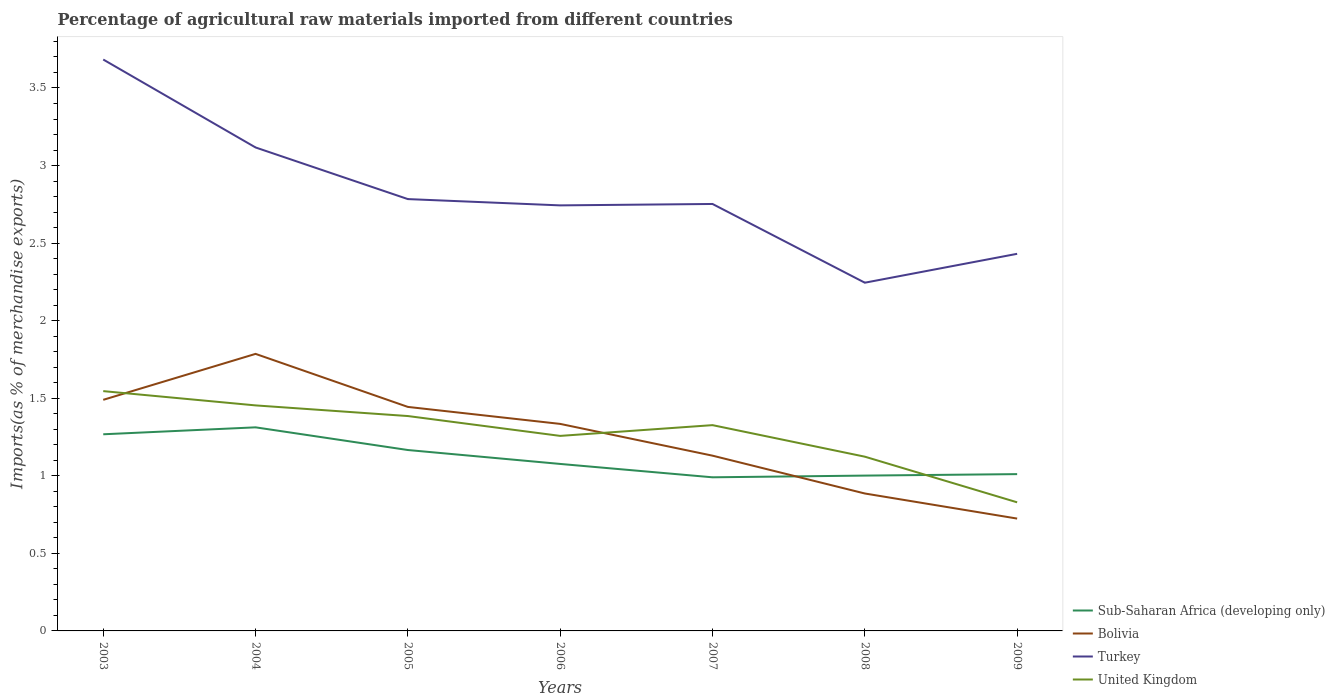Across all years, what is the maximum percentage of imports to different countries in Bolivia?
Provide a succinct answer. 0.72. What is the total percentage of imports to different countries in United Kingdom in the graph?
Keep it short and to the point. 0.43. What is the difference between the highest and the second highest percentage of imports to different countries in Sub-Saharan Africa (developing only)?
Provide a short and direct response. 0.32. Is the percentage of imports to different countries in Sub-Saharan Africa (developing only) strictly greater than the percentage of imports to different countries in Turkey over the years?
Give a very brief answer. Yes. How many lines are there?
Your answer should be compact. 4. How many years are there in the graph?
Offer a very short reply. 7. Are the values on the major ticks of Y-axis written in scientific E-notation?
Ensure brevity in your answer.  No. Does the graph contain grids?
Ensure brevity in your answer.  No. How many legend labels are there?
Offer a terse response. 4. What is the title of the graph?
Offer a very short reply. Percentage of agricultural raw materials imported from different countries. Does "Croatia" appear as one of the legend labels in the graph?
Your answer should be very brief. No. What is the label or title of the X-axis?
Your answer should be very brief. Years. What is the label or title of the Y-axis?
Your response must be concise. Imports(as % of merchandise exports). What is the Imports(as % of merchandise exports) of Sub-Saharan Africa (developing only) in 2003?
Make the answer very short. 1.27. What is the Imports(as % of merchandise exports) in Bolivia in 2003?
Give a very brief answer. 1.49. What is the Imports(as % of merchandise exports) in Turkey in 2003?
Your answer should be very brief. 3.68. What is the Imports(as % of merchandise exports) of United Kingdom in 2003?
Your answer should be compact. 1.55. What is the Imports(as % of merchandise exports) in Sub-Saharan Africa (developing only) in 2004?
Offer a terse response. 1.31. What is the Imports(as % of merchandise exports) in Bolivia in 2004?
Ensure brevity in your answer.  1.79. What is the Imports(as % of merchandise exports) of Turkey in 2004?
Offer a terse response. 3.12. What is the Imports(as % of merchandise exports) of United Kingdom in 2004?
Provide a succinct answer. 1.45. What is the Imports(as % of merchandise exports) in Sub-Saharan Africa (developing only) in 2005?
Provide a succinct answer. 1.17. What is the Imports(as % of merchandise exports) in Bolivia in 2005?
Your answer should be compact. 1.44. What is the Imports(as % of merchandise exports) of Turkey in 2005?
Your answer should be compact. 2.78. What is the Imports(as % of merchandise exports) in United Kingdom in 2005?
Your response must be concise. 1.39. What is the Imports(as % of merchandise exports) of Sub-Saharan Africa (developing only) in 2006?
Your answer should be compact. 1.08. What is the Imports(as % of merchandise exports) of Bolivia in 2006?
Your answer should be compact. 1.33. What is the Imports(as % of merchandise exports) in Turkey in 2006?
Your answer should be very brief. 2.74. What is the Imports(as % of merchandise exports) of United Kingdom in 2006?
Provide a succinct answer. 1.26. What is the Imports(as % of merchandise exports) in Sub-Saharan Africa (developing only) in 2007?
Offer a terse response. 0.99. What is the Imports(as % of merchandise exports) in Bolivia in 2007?
Offer a terse response. 1.13. What is the Imports(as % of merchandise exports) of Turkey in 2007?
Offer a terse response. 2.75. What is the Imports(as % of merchandise exports) in United Kingdom in 2007?
Your response must be concise. 1.33. What is the Imports(as % of merchandise exports) in Sub-Saharan Africa (developing only) in 2008?
Provide a succinct answer. 1. What is the Imports(as % of merchandise exports) of Bolivia in 2008?
Your answer should be compact. 0.89. What is the Imports(as % of merchandise exports) of Turkey in 2008?
Your answer should be compact. 2.24. What is the Imports(as % of merchandise exports) in United Kingdom in 2008?
Provide a succinct answer. 1.12. What is the Imports(as % of merchandise exports) in Sub-Saharan Africa (developing only) in 2009?
Provide a succinct answer. 1.01. What is the Imports(as % of merchandise exports) of Bolivia in 2009?
Ensure brevity in your answer.  0.72. What is the Imports(as % of merchandise exports) of Turkey in 2009?
Keep it short and to the point. 2.43. What is the Imports(as % of merchandise exports) in United Kingdom in 2009?
Offer a terse response. 0.83. Across all years, what is the maximum Imports(as % of merchandise exports) in Sub-Saharan Africa (developing only)?
Provide a succinct answer. 1.31. Across all years, what is the maximum Imports(as % of merchandise exports) of Bolivia?
Your answer should be compact. 1.79. Across all years, what is the maximum Imports(as % of merchandise exports) in Turkey?
Your answer should be very brief. 3.68. Across all years, what is the maximum Imports(as % of merchandise exports) in United Kingdom?
Provide a short and direct response. 1.55. Across all years, what is the minimum Imports(as % of merchandise exports) of Sub-Saharan Africa (developing only)?
Make the answer very short. 0.99. Across all years, what is the minimum Imports(as % of merchandise exports) in Bolivia?
Provide a succinct answer. 0.72. Across all years, what is the minimum Imports(as % of merchandise exports) of Turkey?
Provide a succinct answer. 2.24. Across all years, what is the minimum Imports(as % of merchandise exports) in United Kingdom?
Give a very brief answer. 0.83. What is the total Imports(as % of merchandise exports) of Sub-Saharan Africa (developing only) in the graph?
Ensure brevity in your answer.  7.83. What is the total Imports(as % of merchandise exports) in Bolivia in the graph?
Keep it short and to the point. 8.79. What is the total Imports(as % of merchandise exports) of Turkey in the graph?
Your answer should be compact. 19.76. What is the total Imports(as % of merchandise exports) of United Kingdom in the graph?
Your answer should be compact. 8.92. What is the difference between the Imports(as % of merchandise exports) of Sub-Saharan Africa (developing only) in 2003 and that in 2004?
Offer a terse response. -0.04. What is the difference between the Imports(as % of merchandise exports) in Bolivia in 2003 and that in 2004?
Keep it short and to the point. -0.3. What is the difference between the Imports(as % of merchandise exports) in Turkey in 2003 and that in 2004?
Offer a terse response. 0.57. What is the difference between the Imports(as % of merchandise exports) of United Kingdom in 2003 and that in 2004?
Keep it short and to the point. 0.09. What is the difference between the Imports(as % of merchandise exports) in Sub-Saharan Africa (developing only) in 2003 and that in 2005?
Provide a succinct answer. 0.1. What is the difference between the Imports(as % of merchandise exports) of Bolivia in 2003 and that in 2005?
Keep it short and to the point. 0.05. What is the difference between the Imports(as % of merchandise exports) of Turkey in 2003 and that in 2005?
Keep it short and to the point. 0.9. What is the difference between the Imports(as % of merchandise exports) in United Kingdom in 2003 and that in 2005?
Keep it short and to the point. 0.16. What is the difference between the Imports(as % of merchandise exports) in Sub-Saharan Africa (developing only) in 2003 and that in 2006?
Keep it short and to the point. 0.19. What is the difference between the Imports(as % of merchandise exports) of Bolivia in 2003 and that in 2006?
Provide a short and direct response. 0.16. What is the difference between the Imports(as % of merchandise exports) of Turkey in 2003 and that in 2006?
Make the answer very short. 0.94. What is the difference between the Imports(as % of merchandise exports) in United Kingdom in 2003 and that in 2006?
Make the answer very short. 0.29. What is the difference between the Imports(as % of merchandise exports) of Sub-Saharan Africa (developing only) in 2003 and that in 2007?
Give a very brief answer. 0.28. What is the difference between the Imports(as % of merchandise exports) of Bolivia in 2003 and that in 2007?
Provide a short and direct response. 0.36. What is the difference between the Imports(as % of merchandise exports) of Turkey in 2003 and that in 2007?
Provide a succinct answer. 0.93. What is the difference between the Imports(as % of merchandise exports) of United Kingdom in 2003 and that in 2007?
Offer a terse response. 0.22. What is the difference between the Imports(as % of merchandise exports) in Sub-Saharan Africa (developing only) in 2003 and that in 2008?
Offer a very short reply. 0.27. What is the difference between the Imports(as % of merchandise exports) of Bolivia in 2003 and that in 2008?
Provide a succinct answer. 0.6. What is the difference between the Imports(as % of merchandise exports) in Turkey in 2003 and that in 2008?
Keep it short and to the point. 1.44. What is the difference between the Imports(as % of merchandise exports) of United Kingdom in 2003 and that in 2008?
Your answer should be very brief. 0.42. What is the difference between the Imports(as % of merchandise exports) of Sub-Saharan Africa (developing only) in 2003 and that in 2009?
Your answer should be very brief. 0.26. What is the difference between the Imports(as % of merchandise exports) of Bolivia in 2003 and that in 2009?
Provide a short and direct response. 0.77. What is the difference between the Imports(as % of merchandise exports) in Turkey in 2003 and that in 2009?
Your answer should be compact. 1.25. What is the difference between the Imports(as % of merchandise exports) in United Kingdom in 2003 and that in 2009?
Offer a very short reply. 0.72. What is the difference between the Imports(as % of merchandise exports) of Sub-Saharan Africa (developing only) in 2004 and that in 2005?
Offer a terse response. 0.15. What is the difference between the Imports(as % of merchandise exports) in Bolivia in 2004 and that in 2005?
Keep it short and to the point. 0.34. What is the difference between the Imports(as % of merchandise exports) in Turkey in 2004 and that in 2005?
Give a very brief answer. 0.33. What is the difference between the Imports(as % of merchandise exports) of United Kingdom in 2004 and that in 2005?
Offer a very short reply. 0.07. What is the difference between the Imports(as % of merchandise exports) of Sub-Saharan Africa (developing only) in 2004 and that in 2006?
Provide a short and direct response. 0.24. What is the difference between the Imports(as % of merchandise exports) in Bolivia in 2004 and that in 2006?
Keep it short and to the point. 0.45. What is the difference between the Imports(as % of merchandise exports) in Turkey in 2004 and that in 2006?
Provide a short and direct response. 0.37. What is the difference between the Imports(as % of merchandise exports) in United Kingdom in 2004 and that in 2006?
Make the answer very short. 0.2. What is the difference between the Imports(as % of merchandise exports) of Sub-Saharan Africa (developing only) in 2004 and that in 2007?
Ensure brevity in your answer.  0.32. What is the difference between the Imports(as % of merchandise exports) of Bolivia in 2004 and that in 2007?
Provide a succinct answer. 0.66. What is the difference between the Imports(as % of merchandise exports) in Turkey in 2004 and that in 2007?
Your answer should be compact. 0.36. What is the difference between the Imports(as % of merchandise exports) of United Kingdom in 2004 and that in 2007?
Offer a terse response. 0.13. What is the difference between the Imports(as % of merchandise exports) in Sub-Saharan Africa (developing only) in 2004 and that in 2008?
Offer a very short reply. 0.31. What is the difference between the Imports(as % of merchandise exports) in Bolivia in 2004 and that in 2008?
Offer a very short reply. 0.9. What is the difference between the Imports(as % of merchandise exports) in Turkey in 2004 and that in 2008?
Provide a short and direct response. 0.87. What is the difference between the Imports(as % of merchandise exports) in United Kingdom in 2004 and that in 2008?
Make the answer very short. 0.33. What is the difference between the Imports(as % of merchandise exports) of Sub-Saharan Africa (developing only) in 2004 and that in 2009?
Keep it short and to the point. 0.3. What is the difference between the Imports(as % of merchandise exports) of Bolivia in 2004 and that in 2009?
Your answer should be very brief. 1.06. What is the difference between the Imports(as % of merchandise exports) of Turkey in 2004 and that in 2009?
Your answer should be very brief. 0.69. What is the difference between the Imports(as % of merchandise exports) in United Kingdom in 2004 and that in 2009?
Your response must be concise. 0.62. What is the difference between the Imports(as % of merchandise exports) of Sub-Saharan Africa (developing only) in 2005 and that in 2006?
Keep it short and to the point. 0.09. What is the difference between the Imports(as % of merchandise exports) in Bolivia in 2005 and that in 2006?
Your answer should be very brief. 0.11. What is the difference between the Imports(as % of merchandise exports) in Turkey in 2005 and that in 2006?
Provide a short and direct response. 0.04. What is the difference between the Imports(as % of merchandise exports) in United Kingdom in 2005 and that in 2006?
Keep it short and to the point. 0.13. What is the difference between the Imports(as % of merchandise exports) of Sub-Saharan Africa (developing only) in 2005 and that in 2007?
Ensure brevity in your answer.  0.18. What is the difference between the Imports(as % of merchandise exports) in Bolivia in 2005 and that in 2007?
Your answer should be compact. 0.31. What is the difference between the Imports(as % of merchandise exports) of Turkey in 2005 and that in 2007?
Offer a very short reply. 0.03. What is the difference between the Imports(as % of merchandise exports) in United Kingdom in 2005 and that in 2007?
Offer a terse response. 0.06. What is the difference between the Imports(as % of merchandise exports) of Sub-Saharan Africa (developing only) in 2005 and that in 2008?
Provide a succinct answer. 0.16. What is the difference between the Imports(as % of merchandise exports) of Bolivia in 2005 and that in 2008?
Your response must be concise. 0.56. What is the difference between the Imports(as % of merchandise exports) of Turkey in 2005 and that in 2008?
Keep it short and to the point. 0.54. What is the difference between the Imports(as % of merchandise exports) in United Kingdom in 2005 and that in 2008?
Offer a terse response. 0.26. What is the difference between the Imports(as % of merchandise exports) in Sub-Saharan Africa (developing only) in 2005 and that in 2009?
Offer a terse response. 0.16. What is the difference between the Imports(as % of merchandise exports) in Bolivia in 2005 and that in 2009?
Give a very brief answer. 0.72. What is the difference between the Imports(as % of merchandise exports) of Turkey in 2005 and that in 2009?
Give a very brief answer. 0.35. What is the difference between the Imports(as % of merchandise exports) of United Kingdom in 2005 and that in 2009?
Offer a very short reply. 0.56. What is the difference between the Imports(as % of merchandise exports) of Sub-Saharan Africa (developing only) in 2006 and that in 2007?
Give a very brief answer. 0.09. What is the difference between the Imports(as % of merchandise exports) in Bolivia in 2006 and that in 2007?
Ensure brevity in your answer.  0.2. What is the difference between the Imports(as % of merchandise exports) in Turkey in 2006 and that in 2007?
Offer a very short reply. -0.01. What is the difference between the Imports(as % of merchandise exports) of United Kingdom in 2006 and that in 2007?
Keep it short and to the point. -0.07. What is the difference between the Imports(as % of merchandise exports) in Sub-Saharan Africa (developing only) in 2006 and that in 2008?
Your response must be concise. 0.08. What is the difference between the Imports(as % of merchandise exports) in Bolivia in 2006 and that in 2008?
Keep it short and to the point. 0.45. What is the difference between the Imports(as % of merchandise exports) in Turkey in 2006 and that in 2008?
Ensure brevity in your answer.  0.5. What is the difference between the Imports(as % of merchandise exports) in United Kingdom in 2006 and that in 2008?
Provide a succinct answer. 0.13. What is the difference between the Imports(as % of merchandise exports) of Sub-Saharan Africa (developing only) in 2006 and that in 2009?
Provide a short and direct response. 0.07. What is the difference between the Imports(as % of merchandise exports) in Bolivia in 2006 and that in 2009?
Keep it short and to the point. 0.61. What is the difference between the Imports(as % of merchandise exports) of Turkey in 2006 and that in 2009?
Offer a very short reply. 0.31. What is the difference between the Imports(as % of merchandise exports) of United Kingdom in 2006 and that in 2009?
Offer a very short reply. 0.43. What is the difference between the Imports(as % of merchandise exports) in Sub-Saharan Africa (developing only) in 2007 and that in 2008?
Ensure brevity in your answer.  -0.01. What is the difference between the Imports(as % of merchandise exports) of Bolivia in 2007 and that in 2008?
Provide a succinct answer. 0.24. What is the difference between the Imports(as % of merchandise exports) of Turkey in 2007 and that in 2008?
Ensure brevity in your answer.  0.51. What is the difference between the Imports(as % of merchandise exports) in United Kingdom in 2007 and that in 2008?
Offer a very short reply. 0.2. What is the difference between the Imports(as % of merchandise exports) in Sub-Saharan Africa (developing only) in 2007 and that in 2009?
Make the answer very short. -0.02. What is the difference between the Imports(as % of merchandise exports) of Bolivia in 2007 and that in 2009?
Ensure brevity in your answer.  0.41. What is the difference between the Imports(as % of merchandise exports) in Turkey in 2007 and that in 2009?
Ensure brevity in your answer.  0.32. What is the difference between the Imports(as % of merchandise exports) of United Kingdom in 2007 and that in 2009?
Your response must be concise. 0.5. What is the difference between the Imports(as % of merchandise exports) of Sub-Saharan Africa (developing only) in 2008 and that in 2009?
Make the answer very short. -0.01. What is the difference between the Imports(as % of merchandise exports) in Bolivia in 2008 and that in 2009?
Your answer should be compact. 0.16. What is the difference between the Imports(as % of merchandise exports) of Turkey in 2008 and that in 2009?
Ensure brevity in your answer.  -0.19. What is the difference between the Imports(as % of merchandise exports) of United Kingdom in 2008 and that in 2009?
Your answer should be compact. 0.29. What is the difference between the Imports(as % of merchandise exports) in Sub-Saharan Africa (developing only) in 2003 and the Imports(as % of merchandise exports) in Bolivia in 2004?
Your answer should be compact. -0.52. What is the difference between the Imports(as % of merchandise exports) in Sub-Saharan Africa (developing only) in 2003 and the Imports(as % of merchandise exports) in Turkey in 2004?
Keep it short and to the point. -1.85. What is the difference between the Imports(as % of merchandise exports) in Sub-Saharan Africa (developing only) in 2003 and the Imports(as % of merchandise exports) in United Kingdom in 2004?
Ensure brevity in your answer.  -0.19. What is the difference between the Imports(as % of merchandise exports) in Bolivia in 2003 and the Imports(as % of merchandise exports) in Turkey in 2004?
Your answer should be very brief. -1.63. What is the difference between the Imports(as % of merchandise exports) in Bolivia in 2003 and the Imports(as % of merchandise exports) in United Kingdom in 2004?
Provide a succinct answer. 0.04. What is the difference between the Imports(as % of merchandise exports) in Turkey in 2003 and the Imports(as % of merchandise exports) in United Kingdom in 2004?
Provide a succinct answer. 2.23. What is the difference between the Imports(as % of merchandise exports) of Sub-Saharan Africa (developing only) in 2003 and the Imports(as % of merchandise exports) of Bolivia in 2005?
Your answer should be very brief. -0.18. What is the difference between the Imports(as % of merchandise exports) in Sub-Saharan Africa (developing only) in 2003 and the Imports(as % of merchandise exports) in Turkey in 2005?
Your answer should be very brief. -1.52. What is the difference between the Imports(as % of merchandise exports) of Sub-Saharan Africa (developing only) in 2003 and the Imports(as % of merchandise exports) of United Kingdom in 2005?
Ensure brevity in your answer.  -0.12. What is the difference between the Imports(as % of merchandise exports) in Bolivia in 2003 and the Imports(as % of merchandise exports) in Turkey in 2005?
Your response must be concise. -1.29. What is the difference between the Imports(as % of merchandise exports) in Bolivia in 2003 and the Imports(as % of merchandise exports) in United Kingdom in 2005?
Keep it short and to the point. 0.1. What is the difference between the Imports(as % of merchandise exports) of Turkey in 2003 and the Imports(as % of merchandise exports) of United Kingdom in 2005?
Make the answer very short. 2.3. What is the difference between the Imports(as % of merchandise exports) in Sub-Saharan Africa (developing only) in 2003 and the Imports(as % of merchandise exports) in Bolivia in 2006?
Give a very brief answer. -0.07. What is the difference between the Imports(as % of merchandise exports) of Sub-Saharan Africa (developing only) in 2003 and the Imports(as % of merchandise exports) of Turkey in 2006?
Give a very brief answer. -1.48. What is the difference between the Imports(as % of merchandise exports) in Sub-Saharan Africa (developing only) in 2003 and the Imports(as % of merchandise exports) in United Kingdom in 2006?
Offer a very short reply. 0.01. What is the difference between the Imports(as % of merchandise exports) in Bolivia in 2003 and the Imports(as % of merchandise exports) in Turkey in 2006?
Offer a very short reply. -1.25. What is the difference between the Imports(as % of merchandise exports) in Bolivia in 2003 and the Imports(as % of merchandise exports) in United Kingdom in 2006?
Keep it short and to the point. 0.23. What is the difference between the Imports(as % of merchandise exports) of Turkey in 2003 and the Imports(as % of merchandise exports) of United Kingdom in 2006?
Offer a terse response. 2.43. What is the difference between the Imports(as % of merchandise exports) in Sub-Saharan Africa (developing only) in 2003 and the Imports(as % of merchandise exports) in Bolivia in 2007?
Offer a very short reply. 0.14. What is the difference between the Imports(as % of merchandise exports) of Sub-Saharan Africa (developing only) in 2003 and the Imports(as % of merchandise exports) of Turkey in 2007?
Your answer should be very brief. -1.48. What is the difference between the Imports(as % of merchandise exports) in Sub-Saharan Africa (developing only) in 2003 and the Imports(as % of merchandise exports) in United Kingdom in 2007?
Provide a succinct answer. -0.06. What is the difference between the Imports(as % of merchandise exports) of Bolivia in 2003 and the Imports(as % of merchandise exports) of Turkey in 2007?
Your answer should be very brief. -1.26. What is the difference between the Imports(as % of merchandise exports) in Bolivia in 2003 and the Imports(as % of merchandise exports) in United Kingdom in 2007?
Keep it short and to the point. 0.16. What is the difference between the Imports(as % of merchandise exports) of Turkey in 2003 and the Imports(as % of merchandise exports) of United Kingdom in 2007?
Provide a succinct answer. 2.36. What is the difference between the Imports(as % of merchandise exports) in Sub-Saharan Africa (developing only) in 2003 and the Imports(as % of merchandise exports) in Bolivia in 2008?
Provide a short and direct response. 0.38. What is the difference between the Imports(as % of merchandise exports) in Sub-Saharan Africa (developing only) in 2003 and the Imports(as % of merchandise exports) in Turkey in 2008?
Make the answer very short. -0.98. What is the difference between the Imports(as % of merchandise exports) of Sub-Saharan Africa (developing only) in 2003 and the Imports(as % of merchandise exports) of United Kingdom in 2008?
Provide a short and direct response. 0.14. What is the difference between the Imports(as % of merchandise exports) of Bolivia in 2003 and the Imports(as % of merchandise exports) of Turkey in 2008?
Offer a terse response. -0.76. What is the difference between the Imports(as % of merchandise exports) of Bolivia in 2003 and the Imports(as % of merchandise exports) of United Kingdom in 2008?
Offer a very short reply. 0.37. What is the difference between the Imports(as % of merchandise exports) of Turkey in 2003 and the Imports(as % of merchandise exports) of United Kingdom in 2008?
Make the answer very short. 2.56. What is the difference between the Imports(as % of merchandise exports) in Sub-Saharan Africa (developing only) in 2003 and the Imports(as % of merchandise exports) in Bolivia in 2009?
Make the answer very short. 0.54. What is the difference between the Imports(as % of merchandise exports) of Sub-Saharan Africa (developing only) in 2003 and the Imports(as % of merchandise exports) of Turkey in 2009?
Your response must be concise. -1.16. What is the difference between the Imports(as % of merchandise exports) in Sub-Saharan Africa (developing only) in 2003 and the Imports(as % of merchandise exports) in United Kingdom in 2009?
Offer a very short reply. 0.44. What is the difference between the Imports(as % of merchandise exports) in Bolivia in 2003 and the Imports(as % of merchandise exports) in Turkey in 2009?
Give a very brief answer. -0.94. What is the difference between the Imports(as % of merchandise exports) of Bolivia in 2003 and the Imports(as % of merchandise exports) of United Kingdom in 2009?
Give a very brief answer. 0.66. What is the difference between the Imports(as % of merchandise exports) in Turkey in 2003 and the Imports(as % of merchandise exports) in United Kingdom in 2009?
Give a very brief answer. 2.85. What is the difference between the Imports(as % of merchandise exports) in Sub-Saharan Africa (developing only) in 2004 and the Imports(as % of merchandise exports) in Bolivia in 2005?
Your answer should be compact. -0.13. What is the difference between the Imports(as % of merchandise exports) in Sub-Saharan Africa (developing only) in 2004 and the Imports(as % of merchandise exports) in Turkey in 2005?
Provide a short and direct response. -1.47. What is the difference between the Imports(as % of merchandise exports) in Sub-Saharan Africa (developing only) in 2004 and the Imports(as % of merchandise exports) in United Kingdom in 2005?
Make the answer very short. -0.07. What is the difference between the Imports(as % of merchandise exports) in Bolivia in 2004 and the Imports(as % of merchandise exports) in Turkey in 2005?
Keep it short and to the point. -1. What is the difference between the Imports(as % of merchandise exports) of Bolivia in 2004 and the Imports(as % of merchandise exports) of United Kingdom in 2005?
Offer a very short reply. 0.4. What is the difference between the Imports(as % of merchandise exports) in Turkey in 2004 and the Imports(as % of merchandise exports) in United Kingdom in 2005?
Your response must be concise. 1.73. What is the difference between the Imports(as % of merchandise exports) of Sub-Saharan Africa (developing only) in 2004 and the Imports(as % of merchandise exports) of Bolivia in 2006?
Offer a terse response. -0.02. What is the difference between the Imports(as % of merchandise exports) of Sub-Saharan Africa (developing only) in 2004 and the Imports(as % of merchandise exports) of Turkey in 2006?
Your answer should be very brief. -1.43. What is the difference between the Imports(as % of merchandise exports) of Sub-Saharan Africa (developing only) in 2004 and the Imports(as % of merchandise exports) of United Kingdom in 2006?
Provide a short and direct response. 0.06. What is the difference between the Imports(as % of merchandise exports) of Bolivia in 2004 and the Imports(as % of merchandise exports) of Turkey in 2006?
Your answer should be compact. -0.96. What is the difference between the Imports(as % of merchandise exports) in Bolivia in 2004 and the Imports(as % of merchandise exports) in United Kingdom in 2006?
Make the answer very short. 0.53. What is the difference between the Imports(as % of merchandise exports) of Turkey in 2004 and the Imports(as % of merchandise exports) of United Kingdom in 2006?
Provide a succinct answer. 1.86. What is the difference between the Imports(as % of merchandise exports) in Sub-Saharan Africa (developing only) in 2004 and the Imports(as % of merchandise exports) in Bolivia in 2007?
Your answer should be very brief. 0.18. What is the difference between the Imports(as % of merchandise exports) of Sub-Saharan Africa (developing only) in 2004 and the Imports(as % of merchandise exports) of Turkey in 2007?
Provide a short and direct response. -1.44. What is the difference between the Imports(as % of merchandise exports) of Sub-Saharan Africa (developing only) in 2004 and the Imports(as % of merchandise exports) of United Kingdom in 2007?
Provide a succinct answer. -0.01. What is the difference between the Imports(as % of merchandise exports) of Bolivia in 2004 and the Imports(as % of merchandise exports) of Turkey in 2007?
Your answer should be compact. -0.97. What is the difference between the Imports(as % of merchandise exports) of Bolivia in 2004 and the Imports(as % of merchandise exports) of United Kingdom in 2007?
Offer a very short reply. 0.46. What is the difference between the Imports(as % of merchandise exports) in Turkey in 2004 and the Imports(as % of merchandise exports) in United Kingdom in 2007?
Provide a short and direct response. 1.79. What is the difference between the Imports(as % of merchandise exports) in Sub-Saharan Africa (developing only) in 2004 and the Imports(as % of merchandise exports) in Bolivia in 2008?
Offer a very short reply. 0.43. What is the difference between the Imports(as % of merchandise exports) in Sub-Saharan Africa (developing only) in 2004 and the Imports(as % of merchandise exports) in Turkey in 2008?
Your answer should be compact. -0.93. What is the difference between the Imports(as % of merchandise exports) of Sub-Saharan Africa (developing only) in 2004 and the Imports(as % of merchandise exports) of United Kingdom in 2008?
Provide a short and direct response. 0.19. What is the difference between the Imports(as % of merchandise exports) in Bolivia in 2004 and the Imports(as % of merchandise exports) in Turkey in 2008?
Ensure brevity in your answer.  -0.46. What is the difference between the Imports(as % of merchandise exports) of Bolivia in 2004 and the Imports(as % of merchandise exports) of United Kingdom in 2008?
Offer a terse response. 0.66. What is the difference between the Imports(as % of merchandise exports) in Turkey in 2004 and the Imports(as % of merchandise exports) in United Kingdom in 2008?
Offer a terse response. 1.99. What is the difference between the Imports(as % of merchandise exports) in Sub-Saharan Africa (developing only) in 2004 and the Imports(as % of merchandise exports) in Bolivia in 2009?
Make the answer very short. 0.59. What is the difference between the Imports(as % of merchandise exports) of Sub-Saharan Africa (developing only) in 2004 and the Imports(as % of merchandise exports) of Turkey in 2009?
Keep it short and to the point. -1.12. What is the difference between the Imports(as % of merchandise exports) of Sub-Saharan Africa (developing only) in 2004 and the Imports(as % of merchandise exports) of United Kingdom in 2009?
Offer a terse response. 0.48. What is the difference between the Imports(as % of merchandise exports) in Bolivia in 2004 and the Imports(as % of merchandise exports) in Turkey in 2009?
Offer a very short reply. -0.65. What is the difference between the Imports(as % of merchandise exports) of Bolivia in 2004 and the Imports(as % of merchandise exports) of United Kingdom in 2009?
Give a very brief answer. 0.96. What is the difference between the Imports(as % of merchandise exports) of Turkey in 2004 and the Imports(as % of merchandise exports) of United Kingdom in 2009?
Your answer should be very brief. 2.29. What is the difference between the Imports(as % of merchandise exports) in Sub-Saharan Africa (developing only) in 2005 and the Imports(as % of merchandise exports) in Bolivia in 2006?
Provide a succinct answer. -0.17. What is the difference between the Imports(as % of merchandise exports) in Sub-Saharan Africa (developing only) in 2005 and the Imports(as % of merchandise exports) in Turkey in 2006?
Offer a very short reply. -1.58. What is the difference between the Imports(as % of merchandise exports) of Sub-Saharan Africa (developing only) in 2005 and the Imports(as % of merchandise exports) of United Kingdom in 2006?
Provide a short and direct response. -0.09. What is the difference between the Imports(as % of merchandise exports) in Bolivia in 2005 and the Imports(as % of merchandise exports) in Turkey in 2006?
Make the answer very short. -1.3. What is the difference between the Imports(as % of merchandise exports) of Bolivia in 2005 and the Imports(as % of merchandise exports) of United Kingdom in 2006?
Your answer should be compact. 0.19. What is the difference between the Imports(as % of merchandise exports) of Turkey in 2005 and the Imports(as % of merchandise exports) of United Kingdom in 2006?
Give a very brief answer. 1.53. What is the difference between the Imports(as % of merchandise exports) in Sub-Saharan Africa (developing only) in 2005 and the Imports(as % of merchandise exports) in Bolivia in 2007?
Your answer should be very brief. 0.04. What is the difference between the Imports(as % of merchandise exports) of Sub-Saharan Africa (developing only) in 2005 and the Imports(as % of merchandise exports) of Turkey in 2007?
Your response must be concise. -1.59. What is the difference between the Imports(as % of merchandise exports) of Sub-Saharan Africa (developing only) in 2005 and the Imports(as % of merchandise exports) of United Kingdom in 2007?
Provide a succinct answer. -0.16. What is the difference between the Imports(as % of merchandise exports) in Bolivia in 2005 and the Imports(as % of merchandise exports) in Turkey in 2007?
Your response must be concise. -1.31. What is the difference between the Imports(as % of merchandise exports) of Bolivia in 2005 and the Imports(as % of merchandise exports) of United Kingdom in 2007?
Make the answer very short. 0.12. What is the difference between the Imports(as % of merchandise exports) of Turkey in 2005 and the Imports(as % of merchandise exports) of United Kingdom in 2007?
Offer a terse response. 1.46. What is the difference between the Imports(as % of merchandise exports) of Sub-Saharan Africa (developing only) in 2005 and the Imports(as % of merchandise exports) of Bolivia in 2008?
Your answer should be very brief. 0.28. What is the difference between the Imports(as % of merchandise exports) in Sub-Saharan Africa (developing only) in 2005 and the Imports(as % of merchandise exports) in Turkey in 2008?
Offer a very short reply. -1.08. What is the difference between the Imports(as % of merchandise exports) in Sub-Saharan Africa (developing only) in 2005 and the Imports(as % of merchandise exports) in United Kingdom in 2008?
Make the answer very short. 0.04. What is the difference between the Imports(as % of merchandise exports) of Bolivia in 2005 and the Imports(as % of merchandise exports) of Turkey in 2008?
Keep it short and to the point. -0.8. What is the difference between the Imports(as % of merchandise exports) of Bolivia in 2005 and the Imports(as % of merchandise exports) of United Kingdom in 2008?
Your response must be concise. 0.32. What is the difference between the Imports(as % of merchandise exports) of Turkey in 2005 and the Imports(as % of merchandise exports) of United Kingdom in 2008?
Provide a succinct answer. 1.66. What is the difference between the Imports(as % of merchandise exports) in Sub-Saharan Africa (developing only) in 2005 and the Imports(as % of merchandise exports) in Bolivia in 2009?
Offer a very short reply. 0.44. What is the difference between the Imports(as % of merchandise exports) in Sub-Saharan Africa (developing only) in 2005 and the Imports(as % of merchandise exports) in Turkey in 2009?
Your answer should be compact. -1.26. What is the difference between the Imports(as % of merchandise exports) in Sub-Saharan Africa (developing only) in 2005 and the Imports(as % of merchandise exports) in United Kingdom in 2009?
Provide a short and direct response. 0.34. What is the difference between the Imports(as % of merchandise exports) of Bolivia in 2005 and the Imports(as % of merchandise exports) of Turkey in 2009?
Offer a terse response. -0.99. What is the difference between the Imports(as % of merchandise exports) of Bolivia in 2005 and the Imports(as % of merchandise exports) of United Kingdom in 2009?
Your answer should be compact. 0.61. What is the difference between the Imports(as % of merchandise exports) of Turkey in 2005 and the Imports(as % of merchandise exports) of United Kingdom in 2009?
Your answer should be compact. 1.95. What is the difference between the Imports(as % of merchandise exports) in Sub-Saharan Africa (developing only) in 2006 and the Imports(as % of merchandise exports) in Bolivia in 2007?
Offer a very short reply. -0.05. What is the difference between the Imports(as % of merchandise exports) of Sub-Saharan Africa (developing only) in 2006 and the Imports(as % of merchandise exports) of Turkey in 2007?
Provide a short and direct response. -1.68. What is the difference between the Imports(as % of merchandise exports) of Sub-Saharan Africa (developing only) in 2006 and the Imports(as % of merchandise exports) of United Kingdom in 2007?
Offer a terse response. -0.25. What is the difference between the Imports(as % of merchandise exports) in Bolivia in 2006 and the Imports(as % of merchandise exports) in Turkey in 2007?
Keep it short and to the point. -1.42. What is the difference between the Imports(as % of merchandise exports) of Bolivia in 2006 and the Imports(as % of merchandise exports) of United Kingdom in 2007?
Provide a short and direct response. 0.01. What is the difference between the Imports(as % of merchandise exports) in Turkey in 2006 and the Imports(as % of merchandise exports) in United Kingdom in 2007?
Give a very brief answer. 1.42. What is the difference between the Imports(as % of merchandise exports) of Sub-Saharan Africa (developing only) in 2006 and the Imports(as % of merchandise exports) of Bolivia in 2008?
Ensure brevity in your answer.  0.19. What is the difference between the Imports(as % of merchandise exports) in Sub-Saharan Africa (developing only) in 2006 and the Imports(as % of merchandise exports) in Turkey in 2008?
Provide a succinct answer. -1.17. What is the difference between the Imports(as % of merchandise exports) in Sub-Saharan Africa (developing only) in 2006 and the Imports(as % of merchandise exports) in United Kingdom in 2008?
Make the answer very short. -0.05. What is the difference between the Imports(as % of merchandise exports) in Bolivia in 2006 and the Imports(as % of merchandise exports) in Turkey in 2008?
Give a very brief answer. -0.91. What is the difference between the Imports(as % of merchandise exports) in Bolivia in 2006 and the Imports(as % of merchandise exports) in United Kingdom in 2008?
Make the answer very short. 0.21. What is the difference between the Imports(as % of merchandise exports) in Turkey in 2006 and the Imports(as % of merchandise exports) in United Kingdom in 2008?
Keep it short and to the point. 1.62. What is the difference between the Imports(as % of merchandise exports) in Sub-Saharan Africa (developing only) in 2006 and the Imports(as % of merchandise exports) in Bolivia in 2009?
Your response must be concise. 0.35. What is the difference between the Imports(as % of merchandise exports) of Sub-Saharan Africa (developing only) in 2006 and the Imports(as % of merchandise exports) of Turkey in 2009?
Give a very brief answer. -1.35. What is the difference between the Imports(as % of merchandise exports) of Sub-Saharan Africa (developing only) in 2006 and the Imports(as % of merchandise exports) of United Kingdom in 2009?
Make the answer very short. 0.25. What is the difference between the Imports(as % of merchandise exports) in Bolivia in 2006 and the Imports(as % of merchandise exports) in Turkey in 2009?
Offer a very short reply. -1.1. What is the difference between the Imports(as % of merchandise exports) in Bolivia in 2006 and the Imports(as % of merchandise exports) in United Kingdom in 2009?
Give a very brief answer. 0.51. What is the difference between the Imports(as % of merchandise exports) in Turkey in 2006 and the Imports(as % of merchandise exports) in United Kingdom in 2009?
Give a very brief answer. 1.91. What is the difference between the Imports(as % of merchandise exports) of Sub-Saharan Africa (developing only) in 2007 and the Imports(as % of merchandise exports) of Bolivia in 2008?
Your answer should be very brief. 0.1. What is the difference between the Imports(as % of merchandise exports) of Sub-Saharan Africa (developing only) in 2007 and the Imports(as % of merchandise exports) of Turkey in 2008?
Offer a terse response. -1.25. What is the difference between the Imports(as % of merchandise exports) of Sub-Saharan Africa (developing only) in 2007 and the Imports(as % of merchandise exports) of United Kingdom in 2008?
Provide a short and direct response. -0.13. What is the difference between the Imports(as % of merchandise exports) of Bolivia in 2007 and the Imports(as % of merchandise exports) of Turkey in 2008?
Your response must be concise. -1.11. What is the difference between the Imports(as % of merchandise exports) in Bolivia in 2007 and the Imports(as % of merchandise exports) in United Kingdom in 2008?
Give a very brief answer. 0.01. What is the difference between the Imports(as % of merchandise exports) in Turkey in 2007 and the Imports(as % of merchandise exports) in United Kingdom in 2008?
Ensure brevity in your answer.  1.63. What is the difference between the Imports(as % of merchandise exports) of Sub-Saharan Africa (developing only) in 2007 and the Imports(as % of merchandise exports) of Bolivia in 2009?
Offer a terse response. 0.27. What is the difference between the Imports(as % of merchandise exports) of Sub-Saharan Africa (developing only) in 2007 and the Imports(as % of merchandise exports) of Turkey in 2009?
Provide a short and direct response. -1.44. What is the difference between the Imports(as % of merchandise exports) of Sub-Saharan Africa (developing only) in 2007 and the Imports(as % of merchandise exports) of United Kingdom in 2009?
Your answer should be very brief. 0.16. What is the difference between the Imports(as % of merchandise exports) of Bolivia in 2007 and the Imports(as % of merchandise exports) of Turkey in 2009?
Give a very brief answer. -1.3. What is the difference between the Imports(as % of merchandise exports) of Bolivia in 2007 and the Imports(as % of merchandise exports) of United Kingdom in 2009?
Your answer should be compact. 0.3. What is the difference between the Imports(as % of merchandise exports) in Turkey in 2007 and the Imports(as % of merchandise exports) in United Kingdom in 2009?
Give a very brief answer. 1.92. What is the difference between the Imports(as % of merchandise exports) in Sub-Saharan Africa (developing only) in 2008 and the Imports(as % of merchandise exports) in Bolivia in 2009?
Offer a very short reply. 0.28. What is the difference between the Imports(as % of merchandise exports) in Sub-Saharan Africa (developing only) in 2008 and the Imports(as % of merchandise exports) in Turkey in 2009?
Your answer should be very brief. -1.43. What is the difference between the Imports(as % of merchandise exports) of Sub-Saharan Africa (developing only) in 2008 and the Imports(as % of merchandise exports) of United Kingdom in 2009?
Your answer should be very brief. 0.17. What is the difference between the Imports(as % of merchandise exports) in Bolivia in 2008 and the Imports(as % of merchandise exports) in Turkey in 2009?
Ensure brevity in your answer.  -1.55. What is the difference between the Imports(as % of merchandise exports) of Bolivia in 2008 and the Imports(as % of merchandise exports) of United Kingdom in 2009?
Offer a terse response. 0.06. What is the difference between the Imports(as % of merchandise exports) of Turkey in 2008 and the Imports(as % of merchandise exports) of United Kingdom in 2009?
Give a very brief answer. 1.42. What is the average Imports(as % of merchandise exports) of Sub-Saharan Africa (developing only) per year?
Ensure brevity in your answer.  1.12. What is the average Imports(as % of merchandise exports) in Bolivia per year?
Offer a very short reply. 1.26. What is the average Imports(as % of merchandise exports) of Turkey per year?
Your answer should be compact. 2.82. What is the average Imports(as % of merchandise exports) of United Kingdom per year?
Make the answer very short. 1.27. In the year 2003, what is the difference between the Imports(as % of merchandise exports) of Sub-Saharan Africa (developing only) and Imports(as % of merchandise exports) of Bolivia?
Your answer should be compact. -0.22. In the year 2003, what is the difference between the Imports(as % of merchandise exports) of Sub-Saharan Africa (developing only) and Imports(as % of merchandise exports) of Turkey?
Provide a short and direct response. -2.42. In the year 2003, what is the difference between the Imports(as % of merchandise exports) of Sub-Saharan Africa (developing only) and Imports(as % of merchandise exports) of United Kingdom?
Ensure brevity in your answer.  -0.28. In the year 2003, what is the difference between the Imports(as % of merchandise exports) in Bolivia and Imports(as % of merchandise exports) in Turkey?
Provide a succinct answer. -2.19. In the year 2003, what is the difference between the Imports(as % of merchandise exports) of Bolivia and Imports(as % of merchandise exports) of United Kingdom?
Give a very brief answer. -0.06. In the year 2003, what is the difference between the Imports(as % of merchandise exports) in Turkey and Imports(as % of merchandise exports) in United Kingdom?
Your answer should be compact. 2.14. In the year 2004, what is the difference between the Imports(as % of merchandise exports) in Sub-Saharan Africa (developing only) and Imports(as % of merchandise exports) in Bolivia?
Provide a succinct answer. -0.47. In the year 2004, what is the difference between the Imports(as % of merchandise exports) of Sub-Saharan Africa (developing only) and Imports(as % of merchandise exports) of Turkey?
Keep it short and to the point. -1.8. In the year 2004, what is the difference between the Imports(as % of merchandise exports) of Sub-Saharan Africa (developing only) and Imports(as % of merchandise exports) of United Kingdom?
Your answer should be very brief. -0.14. In the year 2004, what is the difference between the Imports(as % of merchandise exports) of Bolivia and Imports(as % of merchandise exports) of Turkey?
Give a very brief answer. -1.33. In the year 2004, what is the difference between the Imports(as % of merchandise exports) of Bolivia and Imports(as % of merchandise exports) of United Kingdom?
Offer a very short reply. 0.33. In the year 2004, what is the difference between the Imports(as % of merchandise exports) in Turkey and Imports(as % of merchandise exports) in United Kingdom?
Offer a very short reply. 1.66. In the year 2005, what is the difference between the Imports(as % of merchandise exports) of Sub-Saharan Africa (developing only) and Imports(as % of merchandise exports) of Bolivia?
Make the answer very short. -0.28. In the year 2005, what is the difference between the Imports(as % of merchandise exports) in Sub-Saharan Africa (developing only) and Imports(as % of merchandise exports) in Turkey?
Provide a succinct answer. -1.62. In the year 2005, what is the difference between the Imports(as % of merchandise exports) of Sub-Saharan Africa (developing only) and Imports(as % of merchandise exports) of United Kingdom?
Keep it short and to the point. -0.22. In the year 2005, what is the difference between the Imports(as % of merchandise exports) of Bolivia and Imports(as % of merchandise exports) of Turkey?
Provide a short and direct response. -1.34. In the year 2005, what is the difference between the Imports(as % of merchandise exports) in Bolivia and Imports(as % of merchandise exports) in United Kingdom?
Provide a short and direct response. 0.06. In the year 2005, what is the difference between the Imports(as % of merchandise exports) of Turkey and Imports(as % of merchandise exports) of United Kingdom?
Offer a very short reply. 1.4. In the year 2006, what is the difference between the Imports(as % of merchandise exports) of Sub-Saharan Africa (developing only) and Imports(as % of merchandise exports) of Bolivia?
Provide a short and direct response. -0.26. In the year 2006, what is the difference between the Imports(as % of merchandise exports) in Sub-Saharan Africa (developing only) and Imports(as % of merchandise exports) in Turkey?
Ensure brevity in your answer.  -1.67. In the year 2006, what is the difference between the Imports(as % of merchandise exports) in Sub-Saharan Africa (developing only) and Imports(as % of merchandise exports) in United Kingdom?
Make the answer very short. -0.18. In the year 2006, what is the difference between the Imports(as % of merchandise exports) of Bolivia and Imports(as % of merchandise exports) of Turkey?
Give a very brief answer. -1.41. In the year 2006, what is the difference between the Imports(as % of merchandise exports) in Bolivia and Imports(as % of merchandise exports) in United Kingdom?
Offer a terse response. 0.08. In the year 2006, what is the difference between the Imports(as % of merchandise exports) of Turkey and Imports(as % of merchandise exports) of United Kingdom?
Ensure brevity in your answer.  1.49. In the year 2007, what is the difference between the Imports(as % of merchandise exports) in Sub-Saharan Africa (developing only) and Imports(as % of merchandise exports) in Bolivia?
Give a very brief answer. -0.14. In the year 2007, what is the difference between the Imports(as % of merchandise exports) of Sub-Saharan Africa (developing only) and Imports(as % of merchandise exports) of Turkey?
Give a very brief answer. -1.76. In the year 2007, what is the difference between the Imports(as % of merchandise exports) of Sub-Saharan Africa (developing only) and Imports(as % of merchandise exports) of United Kingdom?
Provide a succinct answer. -0.34. In the year 2007, what is the difference between the Imports(as % of merchandise exports) in Bolivia and Imports(as % of merchandise exports) in Turkey?
Keep it short and to the point. -1.62. In the year 2007, what is the difference between the Imports(as % of merchandise exports) in Bolivia and Imports(as % of merchandise exports) in United Kingdom?
Offer a terse response. -0.2. In the year 2007, what is the difference between the Imports(as % of merchandise exports) of Turkey and Imports(as % of merchandise exports) of United Kingdom?
Provide a short and direct response. 1.43. In the year 2008, what is the difference between the Imports(as % of merchandise exports) in Sub-Saharan Africa (developing only) and Imports(as % of merchandise exports) in Bolivia?
Give a very brief answer. 0.12. In the year 2008, what is the difference between the Imports(as % of merchandise exports) of Sub-Saharan Africa (developing only) and Imports(as % of merchandise exports) of Turkey?
Provide a succinct answer. -1.24. In the year 2008, what is the difference between the Imports(as % of merchandise exports) in Sub-Saharan Africa (developing only) and Imports(as % of merchandise exports) in United Kingdom?
Make the answer very short. -0.12. In the year 2008, what is the difference between the Imports(as % of merchandise exports) in Bolivia and Imports(as % of merchandise exports) in Turkey?
Offer a terse response. -1.36. In the year 2008, what is the difference between the Imports(as % of merchandise exports) of Bolivia and Imports(as % of merchandise exports) of United Kingdom?
Provide a short and direct response. -0.24. In the year 2008, what is the difference between the Imports(as % of merchandise exports) in Turkey and Imports(as % of merchandise exports) in United Kingdom?
Provide a succinct answer. 1.12. In the year 2009, what is the difference between the Imports(as % of merchandise exports) of Sub-Saharan Africa (developing only) and Imports(as % of merchandise exports) of Bolivia?
Your answer should be very brief. 0.29. In the year 2009, what is the difference between the Imports(as % of merchandise exports) of Sub-Saharan Africa (developing only) and Imports(as % of merchandise exports) of Turkey?
Your answer should be compact. -1.42. In the year 2009, what is the difference between the Imports(as % of merchandise exports) in Sub-Saharan Africa (developing only) and Imports(as % of merchandise exports) in United Kingdom?
Your answer should be very brief. 0.18. In the year 2009, what is the difference between the Imports(as % of merchandise exports) in Bolivia and Imports(as % of merchandise exports) in Turkey?
Offer a terse response. -1.71. In the year 2009, what is the difference between the Imports(as % of merchandise exports) in Bolivia and Imports(as % of merchandise exports) in United Kingdom?
Ensure brevity in your answer.  -0.1. In the year 2009, what is the difference between the Imports(as % of merchandise exports) of Turkey and Imports(as % of merchandise exports) of United Kingdom?
Your response must be concise. 1.6. What is the ratio of the Imports(as % of merchandise exports) in Sub-Saharan Africa (developing only) in 2003 to that in 2004?
Give a very brief answer. 0.97. What is the ratio of the Imports(as % of merchandise exports) in Bolivia in 2003 to that in 2004?
Your response must be concise. 0.83. What is the ratio of the Imports(as % of merchandise exports) in Turkey in 2003 to that in 2004?
Give a very brief answer. 1.18. What is the ratio of the Imports(as % of merchandise exports) of United Kingdom in 2003 to that in 2004?
Provide a short and direct response. 1.06. What is the ratio of the Imports(as % of merchandise exports) in Sub-Saharan Africa (developing only) in 2003 to that in 2005?
Make the answer very short. 1.09. What is the ratio of the Imports(as % of merchandise exports) in Bolivia in 2003 to that in 2005?
Provide a short and direct response. 1.03. What is the ratio of the Imports(as % of merchandise exports) of Turkey in 2003 to that in 2005?
Your answer should be very brief. 1.32. What is the ratio of the Imports(as % of merchandise exports) of United Kingdom in 2003 to that in 2005?
Your response must be concise. 1.12. What is the ratio of the Imports(as % of merchandise exports) in Sub-Saharan Africa (developing only) in 2003 to that in 2006?
Offer a terse response. 1.18. What is the ratio of the Imports(as % of merchandise exports) in Bolivia in 2003 to that in 2006?
Offer a terse response. 1.12. What is the ratio of the Imports(as % of merchandise exports) in Turkey in 2003 to that in 2006?
Give a very brief answer. 1.34. What is the ratio of the Imports(as % of merchandise exports) in United Kingdom in 2003 to that in 2006?
Your response must be concise. 1.23. What is the ratio of the Imports(as % of merchandise exports) of Sub-Saharan Africa (developing only) in 2003 to that in 2007?
Ensure brevity in your answer.  1.28. What is the ratio of the Imports(as % of merchandise exports) in Bolivia in 2003 to that in 2007?
Ensure brevity in your answer.  1.32. What is the ratio of the Imports(as % of merchandise exports) of Turkey in 2003 to that in 2007?
Provide a short and direct response. 1.34. What is the ratio of the Imports(as % of merchandise exports) in United Kingdom in 2003 to that in 2007?
Offer a very short reply. 1.17. What is the ratio of the Imports(as % of merchandise exports) of Sub-Saharan Africa (developing only) in 2003 to that in 2008?
Your response must be concise. 1.27. What is the ratio of the Imports(as % of merchandise exports) of Bolivia in 2003 to that in 2008?
Provide a short and direct response. 1.68. What is the ratio of the Imports(as % of merchandise exports) of Turkey in 2003 to that in 2008?
Make the answer very short. 1.64. What is the ratio of the Imports(as % of merchandise exports) of United Kingdom in 2003 to that in 2008?
Your answer should be compact. 1.38. What is the ratio of the Imports(as % of merchandise exports) in Sub-Saharan Africa (developing only) in 2003 to that in 2009?
Your response must be concise. 1.25. What is the ratio of the Imports(as % of merchandise exports) of Bolivia in 2003 to that in 2009?
Give a very brief answer. 2.06. What is the ratio of the Imports(as % of merchandise exports) of Turkey in 2003 to that in 2009?
Ensure brevity in your answer.  1.52. What is the ratio of the Imports(as % of merchandise exports) in United Kingdom in 2003 to that in 2009?
Make the answer very short. 1.86. What is the ratio of the Imports(as % of merchandise exports) in Sub-Saharan Africa (developing only) in 2004 to that in 2005?
Provide a short and direct response. 1.13. What is the ratio of the Imports(as % of merchandise exports) in Bolivia in 2004 to that in 2005?
Ensure brevity in your answer.  1.24. What is the ratio of the Imports(as % of merchandise exports) in Turkey in 2004 to that in 2005?
Offer a very short reply. 1.12. What is the ratio of the Imports(as % of merchandise exports) of United Kingdom in 2004 to that in 2005?
Give a very brief answer. 1.05. What is the ratio of the Imports(as % of merchandise exports) in Sub-Saharan Africa (developing only) in 2004 to that in 2006?
Make the answer very short. 1.22. What is the ratio of the Imports(as % of merchandise exports) of Bolivia in 2004 to that in 2006?
Make the answer very short. 1.34. What is the ratio of the Imports(as % of merchandise exports) in Turkey in 2004 to that in 2006?
Make the answer very short. 1.14. What is the ratio of the Imports(as % of merchandise exports) of United Kingdom in 2004 to that in 2006?
Provide a succinct answer. 1.16. What is the ratio of the Imports(as % of merchandise exports) in Sub-Saharan Africa (developing only) in 2004 to that in 2007?
Ensure brevity in your answer.  1.33. What is the ratio of the Imports(as % of merchandise exports) of Bolivia in 2004 to that in 2007?
Provide a succinct answer. 1.58. What is the ratio of the Imports(as % of merchandise exports) of Turkey in 2004 to that in 2007?
Offer a very short reply. 1.13. What is the ratio of the Imports(as % of merchandise exports) of United Kingdom in 2004 to that in 2007?
Ensure brevity in your answer.  1.1. What is the ratio of the Imports(as % of merchandise exports) in Sub-Saharan Africa (developing only) in 2004 to that in 2008?
Keep it short and to the point. 1.31. What is the ratio of the Imports(as % of merchandise exports) in Bolivia in 2004 to that in 2008?
Your response must be concise. 2.02. What is the ratio of the Imports(as % of merchandise exports) of Turkey in 2004 to that in 2008?
Offer a terse response. 1.39. What is the ratio of the Imports(as % of merchandise exports) in United Kingdom in 2004 to that in 2008?
Make the answer very short. 1.29. What is the ratio of the Imports(as % of merchandise exports) of Sub-Saharan Africa (developing only) in 2004 to that in 2009?
Offer a very short reply. 1.3. What is the ratio of the Imports(as % of merchandise exports) in Bolivia in 2004 to that in 2009?
Keep it short and to the point. 2.47. What is the ratio of the Imports(as % of merchandise exports) in Turkey in 2004 to that in 2009?
Offer a very short reply. 1.28. What is the ratio of the Imports(as % of merchandise exports) of United Kingdom in 2004 to that in 2009?
Offer a very short reply. 1.75. What is the ratio of the Imports(as % of merchandise exports) in Sub-Saharan Africa (developing only) in 2005 to that in 2006?
Give a very brief answer. 1.08. What is the ratio of the Imports(as % of merchandise exports) in Bolivia in 2005 to that in 2006?
Your answer should be compact. 1.08. What is the ratio of the Imports(as % of merchandise exports) of Turkey in 2005 to that in 2006?
Offer a terse response. 1.01. What is the ratio of the Imports(as % of merchandise exports) of United Kingdom in 2005 to that in 2006?
Your response must be concise. 1.1. What is the ratio of the Imports(as % of merchandise exports) of Sub-Saharan Africa (developing only) in 2005 to that in 2007?
Keep it short and to the point. 1.18. What is the ratio of the Imports(as % of merchandise exports) of Bolivia in 2005 to that in 2007?
Offer a very short reply. 1.28. What is the ratio of the Imports(as % of merchandise exports) of Turkey in 2005 to that in 2007?
Offer a terse response. 1.01. What is the ratio of the Imports(as % of merchandise exports) of United Kingdom in 2005 to that in 2007?
Provide a short and direct response. 1.04. What is the ratio of the Imports(as % of merchandise exports) in Sub-Saharan Africa (developing only) in 2005 to that in 2008?
Offer a very short reply. 1.16. What is the ratio of the Imports(as % of merchandise exports) in Bolivia in 2005 to that in 2008?
Keep it short and to the point. 1.63. What is the ratio of the Imports(as % of merchandise exports) of Turkey in 2005 to that in 2008?
Your response must be concise. 1.24. What is the ratio of the Imports(as % of merchandise exports) of United Kingdom in 2005 to that in 2008?
Give a very brief answer. 1.23. What is the ratio of the Imports(as % of merchandise exports) in Sub-Saharan Africa (developing only) in 2005 to that in 2009?
Give a very brief answer. 1.15. What is the ratio of the Imports(as % of merchandise exports) in Bolivia in 2005 to that in 2009?
Make the answer very short. 1.99. What is the ratio of the Imports(as % of merchandise exports) of Turkey in 2005 to that in 2009?
Your answer should be very brief. 1.15. What is the ratio of the Imports(as % of merchandise exports) in United Kingdom in 2005 to that in 2009?
Your answer should be very brief. 1.67. What is the ratio of the Imports(as % of merchandise exports) of Sub-Saharan Africa (developing only) in 2006 to that in 2007?
Give a very brief answer. 1.09. What is the ratio of the Imports(as % of merchandise exports) of Bolivia in 2006 to that in 2007?
Keep it short and to the point. 1.18. What is the ratio of the Imports(as % of merchandise exports) in Turkey in 2006 to that in 2007?
Provide a short and direct response. 1. What is the ratio of the Imports(as % of merchandise exports) in United Kingdom in 2006 to that in 2007?
Make the answer very short. 0.95. What is the ratio of the Imports(as % of merchandise exports) in Sub-Saharan Africa (developing only) in 2006 to that in 2008?
Ensure brevity in your answer.  1.07. What is the ratio of the Imports(as % of merchandise exports) of Bolivia in 2006 to that in 2008?
Offer a terse response. 1.51. What is the ratio of the Imports(as % of merchandise exports) of Turkey in 2006 to that in 2008?
Keep it short and to the point. 1.22. What is the ratio of the Imports(as % of merchandise exports) of United Kingdom in 2006 to that in 2008?
Make the answer very short. 1.12. What is the ratio of the Imports(as % of merchandise exports) of Sub-Saharan Africa (developing only) in 2006 to that in 2009?
Offer a terse response. 1.06. What is the ratio of the Imports(as % of merchandise exports) of Bolivia in 2006 to that in 2009?
Provide a short and direct response. 1.84. What is the ratio of the Imports(as % of merchandise exports) in Turkey in 2006 to that in 2009?
Keep it short and to the point. 1.13. What is the ratio of the Imports(as % of merchandise exports) of United Kingdom in 2006 to that in 2009?
Keep it short and to the point. 1.52. What is the ratio of the Imports(as % of merchandise exports) in Sub-Saharan Africa (developing only) in 2007 to that in 2008?
Ensure brevity in your answer.  0.99. What is the ratio of the Imports(as % of merchandise exports) in Bolivia in 2007 to that in 2008?
Offer a very short reply. 1.28. What is the ratio of the Imports(as % of merchandise exports) in Turkey in 2007 to that in 2008?
Make the answer very short. 1.23. What is the ratio of the Imports(as % of merchandise exports) in United Kingdom in 2007 to that in 2008?
Provide a short and direct response. 1.18. What is the ratio of the Imports(as % of merchandise exports) in Sub-Saharan Africa (developing only) in 2007 to that in 2009?
Ensure brevity in your answer.  0.98. What is the ratio of the Imports(as % of merchandise exports) in Bolivia in 2007 to that in 2009?
Keep it short and to the point. 1.56. What is the ratio of the Imports(as % of merchandise exports) of Turkey in 2007 to that in 2009?
Provide a short and direct response. 1.13. What is the ratio of the Imports(as % of merchandise exports) of United Kingdom in 2007 to that in 2009?
Provide a short and direct response. 1.6. What is the ratio of the Imports(as % of merchandise exports) in Sub-Saharan Africa (developing only) in 2008 to that in 2009?
Ensure brevity in your answer.  0.99. What is the ratio of the Imports(as % of merchandise exports) in Bolivia in 2008 to that in 2009?
Provide a short and direct response. 1.22. What is the ratio of the Imports(as % of merchandise exports) in Turkey in 2008 to that in 2009?
Your response must be concise. 0.92. What is the ratio of the Imports(as % of merchandise exports) in United Kingdom in 2008 to that in 2009?
Ensure brevity in your answer.  1.35. What is the difference between the highest and the second highest Imports(as % of merchandise exports) of Sub-Saharan Africa (developing only)?
Your answer should be very brief. 0.04. What is the difference between the highest and the second highest Imports(as % of merchandise exports) of Bolivia?
Your response must be concise. 0.3. What is the difference between the highest and the second highest Imports(as % of merchandise exports) of Turkey?
Ensure brevity in your answer.  0.57. What is the difference between the highest and the second highest Imports(as % of merchandise exports) of United Kingdom?
Make the answer very short. 0.09. What is the difference between the highest and the lowest Imports(as % of merchandise exports) of Sub-Saharan Africa (developing only)?
Keep it short and to the point. 0.32. What is the difference between the highest and the lowest Imports(as % of merchandise exports) of Bolivia?
Your response must be concise. 1.06. What is the difference between the highest and the lowest Imports(as % of merchandise exports) of Turkey?
Offer a terse response. 1.44. What is the difference between the highest and the lowest Imports(as % of merchandise exports) in United Kingdom?
Offer a terse response. 0.72. 